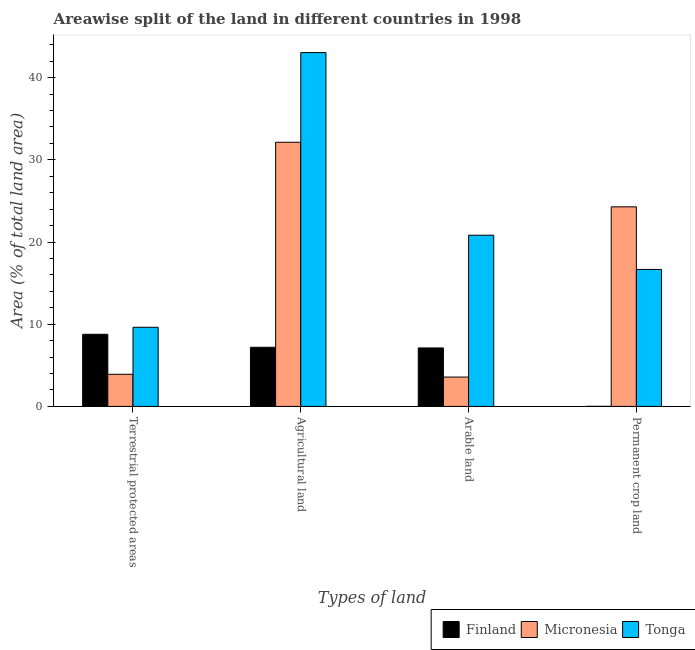Are the number of bars on each tick of the X-axis equal?
Give a very brief answer. Yes. How many bars are there on the 3rd tick from the right?
Offer a terse response. 3. What is the label of the 3rd group of bars from the left?
Keep it short and to the point. Arable land. What is the percentage of area under permanent crop land in Finland?
Offer a very short reply. 0.01. Across all countries, what is the maximum percentage of area under permanent crop land?
Keep it short and to the point. 24.29. Across all countries, what is the minimum percentage of area under permanent crop land?
Your answer should be compact. 0.01. In which country was the percentage of area under arable land maximum?
Keep it short and to the point. Tonga. In which country was the percentage of area under agricultural land minimum?
Make the answer very short. Finland. What is the total percentage of area under agricultural land in the graph?
Keep it short and to the point. 82.39. What is the difference between the percentage of land under terrestrial protection in Finland and that in Micronesia?
Your response must be concise. 4.87. What is the difference between the percentage of area under permanent crop land in Tonga and the percentage of area under agricultural land in Micronesia?
Offer a very short reply. -15.48. What is the average percentage of area under permanent crop land per country?
Give a very brief answer. 13.65. What is the difference between the percentage of area under permanent crop land and percentage of area under agricultural land in Micronesia?
Provide a succinct answer. -7.86. In how many countries, is the percentage of area under arable land greater than 2 %?
Ensure brevity in your answer.  3. What is the ratio of the percentage of area under permanent crop land in Tonga to that in Finland?
Your answer should be compact. 1586.41. Is the percentage of area under arable land in Tonga less than that in Micronesia?
Your response must be concise. No. What is the difference between the highest and the second highest percentage of area under agricultural land?
Your answer should be very brief. 10.91. What is the difference between the highest and the lowest percentage of area under arable land?
Provide a short and direct response. 17.26. In how many countries, is the percentage of land under terrestrial protection greater than the average percentage of land under terrestrial protection taken over all countries?
Ensure brevity in your answer.  2. What does the 3rd bar from the left in Agricultural land represents?
Give a very brief answer. Tonga. What does the 3rd bar from the right in Permanent crop land represents?
Offer a terse response. Finland. Are all the bars in the graph horizontal?
Offer a terse response. No. How many countries are there in the graph?
Give a very brief answer. 3. What is the difference between two consecutive major ticks on the Y-axis?
Your response must be concise. 10. Are the values on the major ticks of Y-axis written in scientific E-notation?
Your answer should be compact. No. Does the graph contain any zero values?
Provide a succinct answer. No. How many legend labels are there?
Provide a succinct answer. 3. What is the title of the graph?
Offer a very short reply. Areawise split of the land in different countries in 1998. Does "Switzerland" appear as one of the legend labels in the graph?
Ensure brevity in your answer.  No. What is the label or title of the X-axis?
Ensure brevity in your answer.  Types of land. What is the label or title of the Y-axis?
Keep it short and to the point. Area (% of total land area). What is the Area (% of total land area) in Finland in Terrestrial protected areas?
Make the answer very short. 8.78. What is the Area (% of total land area) of Micronesia in Terrestrial protected areas?
Make the answer very short. 3.91. What is the Area (% of total land area) in Tonga in Terrestrial protected areas?
Give a very brief answer. 9.63. What is the Area (% of total land area) of Finland in Agricultural land?
Your answer should be very brief. 7.2. What is the Area (% of total land area) of Micronesia in Agricultural land?
Give a very brief answer. 32.14. What is the Area (% of total land area) in Tonga in Agricultural land?
Keep it short and to the point. 43.06. What is the Area (% of total land area) of Finland in Arable land?
Your answer should be compact. 7.12. What is the Area (% of total land area) in Micronesia in Arable land?
Offer a terse response. 3.57. What is the Area (% of total land area) of Tonga in Arable land?
Ensure brevity in your answer.  20.83. What is the Area (% of total land area) in Finland in Permanent crop land?
Provide a succinct answer. 0.01. What is the Area (% of total land area) of Micronesia in Permanent crop land?
Your answer should be very brief. 24.29. What is the Area (% of total land area) of Tonga in Permanent crop land?
Offer a terse response. 16.67. Across all Types of land, what is the maximum Area (% of total land area) of Finland?
Your answer should be compact. 8.78. Across all Types of land, what is the maximum Area (% of total land area) of Micronesia?
Your answer should be compact. 32.14. Across all Types of land, what is the maximum Area (% of total land area) of Tonga?
Your answer should be very brief. 43.06. Across all Types of land, what is the minimum Area (% of total land area) of Finland?
Keep it short and to the point. 0.01. Across all Types of land, what is the minimum Area (% of total land area) of Micronesia?
Your response must be concise. 3.57. Across all Types of land, what is the minimum Area (% of total land area) of Tonga?
Your response must be concise. 9.63. What is the total Area (% of total land area) in Finland in the graph?
Your answer should be very brief. 23.1. What is the total Area (% of total land area) in Micronesia in the graph?
Your answer should be very brief. 63.91. What is the total Area (% of total land area) in Tonga in the graph?
Keep it short and to the point. 90.19. What is the difference between the Area (% of total land area) in Finland in Terrestrial protected areas and that in Agricultural land?
Make the answer very short. 1.58. What is the difference between the Area (% of total land area) in Micronesia in Terrestrial protected areas and that in Agricultural land?
Ensure brevity in your answer.  -28.23. What is the difference between the Area (% of total land area) of Tonga in Terrestrial protected areas and that in Agricultural land?
Your answer should be compact. -33.43. What is the difference between the Area (% of total land area) of Finland in Terrestrial protected areas and that in Arable land?
Your answer should be compact. 1.66. What is the difference between the Area (% of total land area) of Micronesia in Terrestrial protected areas and that in Arable land?
Ensure brevity in your answer.  0.34. What is the difference between the Area (% of total land area) in Tonga in Terrestrial protected areas and that in Arable land?
Keep it short and to the point. -11.2. What is the difference between the Area (% of total land area) of Finland in Terrestrial protected areas and that in Permanent crop land?
Your answer should be very brief. 8.77. What is the difference between the Area (% of total land area) in Micronesia in Terrestrial protected areas and that in Permanent crop land?
Your answer should be compact. -20.38. What is the difference between the Area (% of total land area) in Tonga in Terrestrial protected areas and that in Permanent crop land?
Offer a very short reply. -7.04. What is the difference between the Area (% of total land area) of Finland in Agricultural land and that in Arable land?
Your answer should be very brief. 0.08. What is the difference between the Area (% of total land area) of Micronesia in Agricultural land and that in Arable land?
Your answer should be very brief. 28.57. What is the difference between the Area (% of total land area) of Tonga in Agricultural land and that in Arable land?
Your response must be concise. 22.22. What is the difference between the Area (% of total land area) in Finland in Agricultural land and that in Permanent crop land?
Give a very brief answer. 7.19. What is the difference between the Area (% of total land area) of Micronesia in Agricultural land and that in Permanent crop land?
Ensure brevity in your answer.  7.86. What is the difference between the Area (% of total land area) of Tonga in Agricultural land and that in Permanent crop land?
Offer a very short reply. 26.39. What is the difference between the Area (% of total land area) of Finland in Arable land and that in Permanent crop land?
Make the answer very short. 7.1. What is the difference between the Area (% of total land area) of Micronesia in Arable land and that in Permanent crop land?
Make the answer very short. -20.71. What is the difference between the Area (% of total land area) of Tonga in Arable land and that in Permanent crop land?
Make the answer very short. 4.17. What is the difference between the Area (% of total land area) of Finland in Terrestrial protected areas and the Area (% of total land area) of Micronesia in Agricultural land?
Provide a short and direct response. -23.37. What is the difference between the Area (% of total land area) of Finland in Terrestrial protected areas and the Area (% of total land area) of Tonga in Agricultural land?
Offer a very short reply. -34.28. What is the difference between the Area (% of total land area) of Micronesia in Terrestrial protected areas and the Area (% of total land area) of Tonga in Agricultural land?
Offer a very short reply. -39.15. What is the difference between the Area (% of total land area) of Finland in Terrestrial protected areas and the Area (% of total land area) of Micronesia in Arable land?
Give a very brief answer. 5.21. What is the difference between the Area (% of total land area) in Finland in Terrestrial protected areas and the Area (% of total land area) in Tonga in Arable land?
Give a very brief answer. -12.06. What is the difference between the Area (% of total land area) of Micronesia in Terrestrial protected areas and the Area (% of total land area) of Tonga in Arable land?
Ensure brevity in your answer.  -16.92. What is the difference between the Area (% of total land area) of Finland in Terrestrial protected areas and the Area (% of total land area) of Micronesia in Permanent crop land?
Keep it short and to the point. -15.51. What is the difference between the Area (% of total land area) of Finland in Terrestrial protected areas and the Area (% of total land area) of Tonga in Permanent crop land?
Keep it short and to the point. -7.89. What is the difference between the Area (% of total land area) in Micronesia in Terrestrial protected areas and the Area (% of total land area) in Tonga in Permanent crop land?
Make the answer very short. -12.76. What is the difference between the Area (% of total land area) in Finland in Agricultural land and the Area (% of total land area) in Micronesia in Arable land?
Keep it short and to the point. 3.63. What is the difference between the Area (% of total land area) of Finland in Agricultural land and the Area (% of total land area) of Tonga in Arable land?
Your answer should be compact. -13.64. What is the difference between the Area (% of total land area) in Micronesia in Agricultural land and the Area (% of total land area) in Tonga in Arable land?
Your answer should be very brief. 11.31. What is the difference between the Area (% of total land area) of Finland in Agricultural land and the Area (% of total land area) of Micronesia in Permanent crop land?
Keep it short and to the point. -17.09. What is the difference between the Area (% of total land area) of Finland in Agricultural land and the Area (% of total land area) of Tonga in Permanent crop land?
Your answer should be compact. -9.47. What is the difference between the Area (% of total land area) of Micronesia in Agricultural land and the Area (% of total land area) of Tonga in Permanent crop land?
Your response must be concise. 15.48. What is the difference between the Area (% of total land area) in Finland in Arable land and the Area (% of total land area) in Micronesia in Permanent crop land?
Provide a succinct answer. -17.17. What is the difference between the Area (% of total land area) of Finland in Arable land and the Area (% of total land area) of Tonga in Permanent crop land?
Offer a very short reply. -9.55. What is the difference between the Area (% of total land area) in Micronesia in Arable land and the Area (% of total land area) in Tonga in Permanent crop land?
Keep it short and to the point. -13.1. What is the average Area (% of total land area) in Finland per Types of land?
Your answer should be very brief. 5.77. What is the average Area (% of total land area) in Micronesia per Types of land?
Your answer should be compact. 15.98. What is the average Area (% of total land area) of Tonga per Types of land?
Provide a succinct answer. 22.55. What is the difference between the Area (% of total land area) in Finland and Area (% of total land area) in Micronesia in Terrestrial protected areas?
Your answer should be very brief. 4.87. What is the difference between the Area (% of total land area) in Finland and Area (% of total land area) in Tonga in Terrestrial protected areas?
Keep it short and to the point. -0.85. What is the difference between the Area (% of total land area) of Micronesia and Area (% of total land area) of Tonga in Terrestrial protected areas?
Offer a terse response. -5.72. What is the difference between the Area (% of total land area) in Finland and Area (% of total land area) in Micronesia in Agricultural land?
Provide a succinct answer. -24.95. What is the difference between the Area (% of total land area) in Finland and Area (% of total land area) in Tonga in Agricultural land?
Offer a terse response. -35.86. What is the difference between the Area (% of total land area) in Micronesia and Area (% of total land area) in Tonga in Agricultural land?
Your response must be concise. -10.91. What is the difference between the Area (% of total land area) of Finland and Area (% of total land area) of Micronesia in Arable land?
Offer a very short reply. 3.54. What is the difference between the Area (% of total land area) in Finland and Area (% of total land area) in Tonga in Arable land?
Offer a very short reply. -13.72. What is the difference between the Area (% of total land area) in Micronesia and Area (% of total land area) in Tonga in Arable land?
Your response must be concise. -17.26. What is the difference between the Area (% of total land area) of Finland and Area (% of total land area) of Micronesia in Permanent crop land?
Your response must be concise. -24.28. What is the difference between the Area (% of total land area) in Finland and Area (% of total land area) in Tonga in Permanent crop land?
Your answer should be compact. -16.66. What is the difference between the Area (% of total land area) of Micronesia and Area (% of total land area) of Tonga in Permanent crop land?
Your response must be concise. 7.62. What is the ratio of the Area (% of total land area) of Finland in Terrestrial protected areas to that in Agricultural land?
Your answer should be very brief. 1.22. What is the ratio of the Area (% of total land area) of Micronesia in Terrestrial protected areas to that in Agricultural land?
Your response must be concise. 0.12. What is the ratio of the Area (% of total land area) in Tonga in Terrestrial protected areas to that in Agricultural land?
Give a very brief answer. 0.22. What is the ratio of the Area (% of total land area) of Finland in Terrestrial protected areas to that in Arable land?
Make the answer very short. 1.23. What is the ratio of the Area (% of total land area) of Micronesia in Terrestrial protected areas to that in Arable land?
Your answer should be compact. 1.09. What is the ratio of the Area (% of total land area) in Tonga in Terrestrial protected areas to that in Arable land?
Make the answer very short. 0.46. What is the ratio of the Area (% of total land area) in Finland in Terrestrial protected areas to that in Permanent crop land?
Offer a very short reply. 835.47. What is the ratio of the Area (% of total land area) in Micronesia in Terrestrial protected areas to that in Permanent crop land?
Provide a succinct answer. 0.16. What is the ratio of the Area (% of total land area) in Tonga in Terrestrial protected areas to that in Permanent crop land?
Offer a terse response. 0.58. What is the ratio of the Area (% of total land area) in Finland in Agricultural land to that in Arable land?
Your answer should be compact. 1.01. What is the ratio of the Area (% of total land area) of Tonga in Agricultural land to that in Arable land?
Provide a succinct answer. 2.07. What is the ratio of the Area (% of total land area) of Finland in Agricultural land to that in Permanent crop land?
Give a very brief answer. 685. What is the ratio of the Area (% of total land area) of Micronesia in Agricultural land to that in Permanent crop land?
Offer a terse response. 1.32. What is the ratio of the Area (% of total land area) in Tonga in Agricultural land to that in Permanent crop land?
Offer a very short reply. 2.58. What is the ratio of the Area (% of total land area) in Finland in Arable land to that in Permanent crop land?
Make the answer very short. 677.25. What is the ratio of the Area (% of total land area) in Micronesia in Arable land to that in Permanent crop land?
Your answer should be compact. 0.15. What is the difference between the highest and the second highest Area (% of total land area) of Finland?
Keep it short and to the point. 1.58. What is the difference between the highest and the second highest Area (% of total land area) of Micronesia?
Ensure brevity in your answer.  7.86. What is the difference between the highest and the second highest Area (% of total land area) of Tonga?
Keep it short and to the point. 22.22. What is the difference between the highest and the lowest Area (% of total land area) of Finland?
Your answer should be compact. 8.77. What is the difference between the highest and the lowest Area (% of total land area) in Micronesia?
Make the answer very short. 28.57. What is the difference between the highest and the lowest Area (% of total land area) of Tonga?
Give a very brief answer. 33.43. 